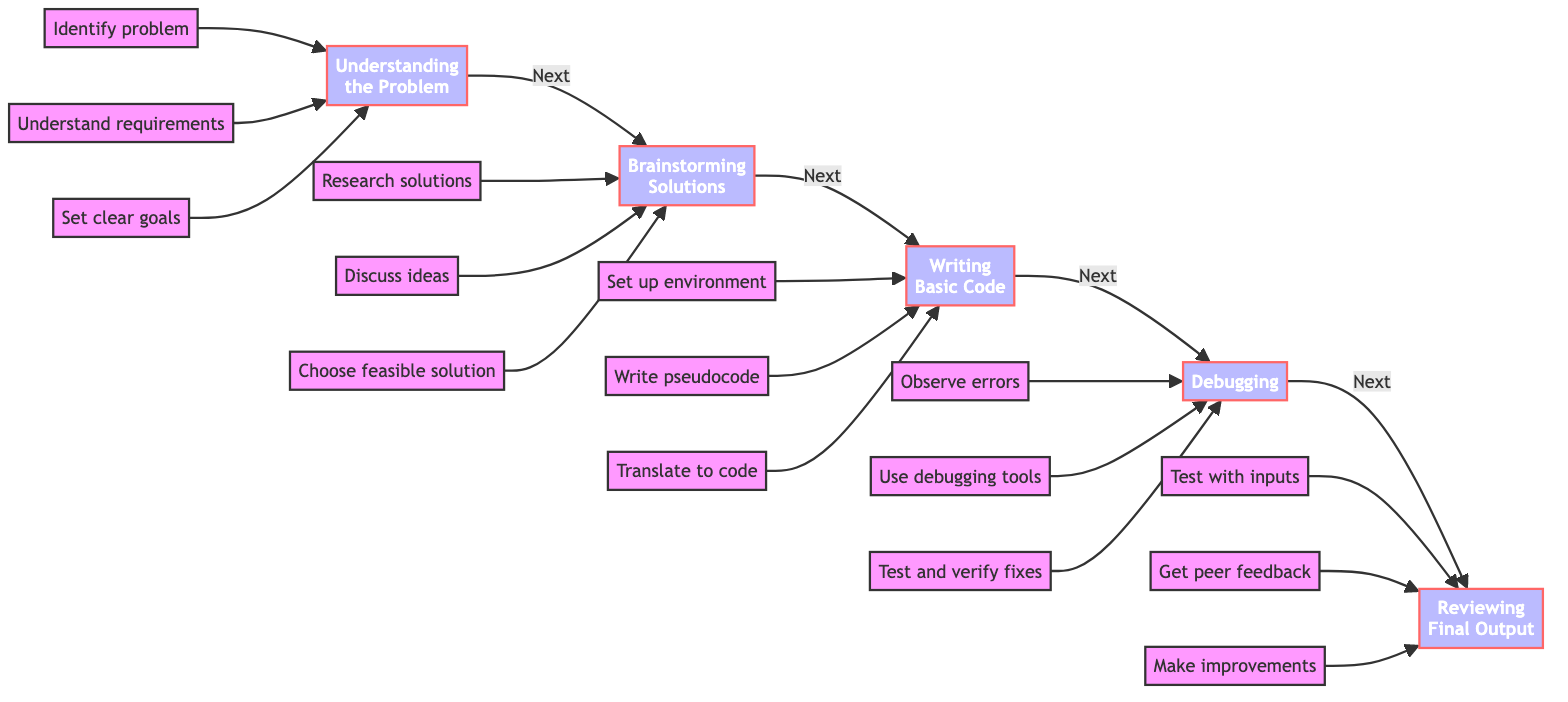What is the first step in the project development process? The diagram indicates that the first step in the project development process is "Understanding the Problem," which is the starting node before any other steps.
Answer: Understanding the Problem How many main phases are there in the flowchart? By counting the distinct phases represented in the flowchart, we can identify that there are five main phases: Understanding the Problem, Brainstorming Solutions, Writing Basic Code, Debugging, and Reviewing Final Output.
Answer: Five Which phase comes after "Writing Basic Code"? The diagram shows a direct flow from "Writing Basic Code" to "Debugging," indicating that debugging is the phase that follows the coding step.
Answer: Debugging What action is involved in the "Reviewing Final Output" phase? One of the actions specified under "Reviewing Final Output" is to "Get peer feedback," which highlights the importance of collaboration in the review process.
Answer: Get peer feedback What is the last action in the flowchart? The final action indicated in the flowchart occurs in the "Reviewing Final Output" phase, which is to "Make improvements," showing that the project reflects continual enhancement even at the end.
Answer: Make improvements Which action must be taken before "Debugging"? Before debugging can begin, one must complete the "Writing Basic Code" phase, where the actual code is developed based on the chosen solution.
Answer: Writing Basic Code How do the nodes connect from "Understanding the Problem" to "Reviewing Final Output"? The connection from "Understanding the Problem" moves through a sequential path: first to "Brainstorming Solutions," then to "Writing Basic Code," followed by "Debugging," and finally ending with "Reviewing Final Output," illustrating a linear progression in the workflow.
Answer: Sequentially How many elements are involved in the "Debugging" phase? In the "Debugging" phase, there are three specific actions listed, which include running the code, using debugging tools, and testing each fix, making a total of three elements involved.
Answer: Three 